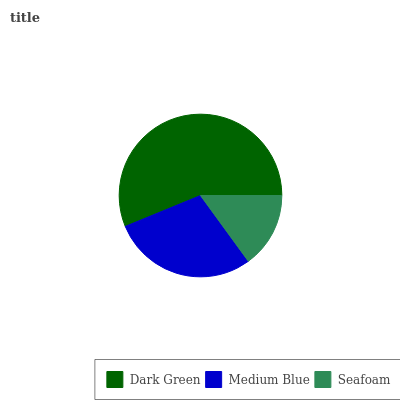Is Seafoam the minimum?
Answer yes or no. Yes. Is Dark Green the maximum?
Answer yes or no. Yes. Is Medium Blue the minimum?
Answer yes or no. No. Is Medium Blue the maximum?
Answer yes or no. No. Is Dark Green greater than Medium Blue?
Answer yes or no. Yes. Is Medium Blue less than Dark Green?
Answer yes or no. Yes. Is Medium Blue greater than Dark Green?
Answer yes or no. No. Is Dark Green less than Medium Blue?
Answer yes or no. No. Is Medium Blue the high median?
Answer yes or no. Yes. Is Medium Blue the low median?
Answer yes or no. Yes. Is Seafoam the high median?
Answer yes or no. No. Is Dark Green the low median?
Answer yes or no. No. 